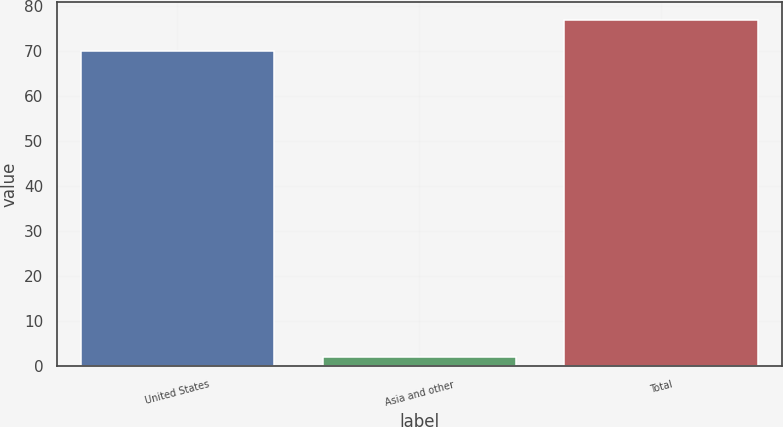<chart> <loc_0><loc_0><loc_500><loc_500><bar_chart><fcel>United States<fcel>Asia and other<fcel>Total<nl><fcel>70<fcel>2<fcel>77<nl></chart> 